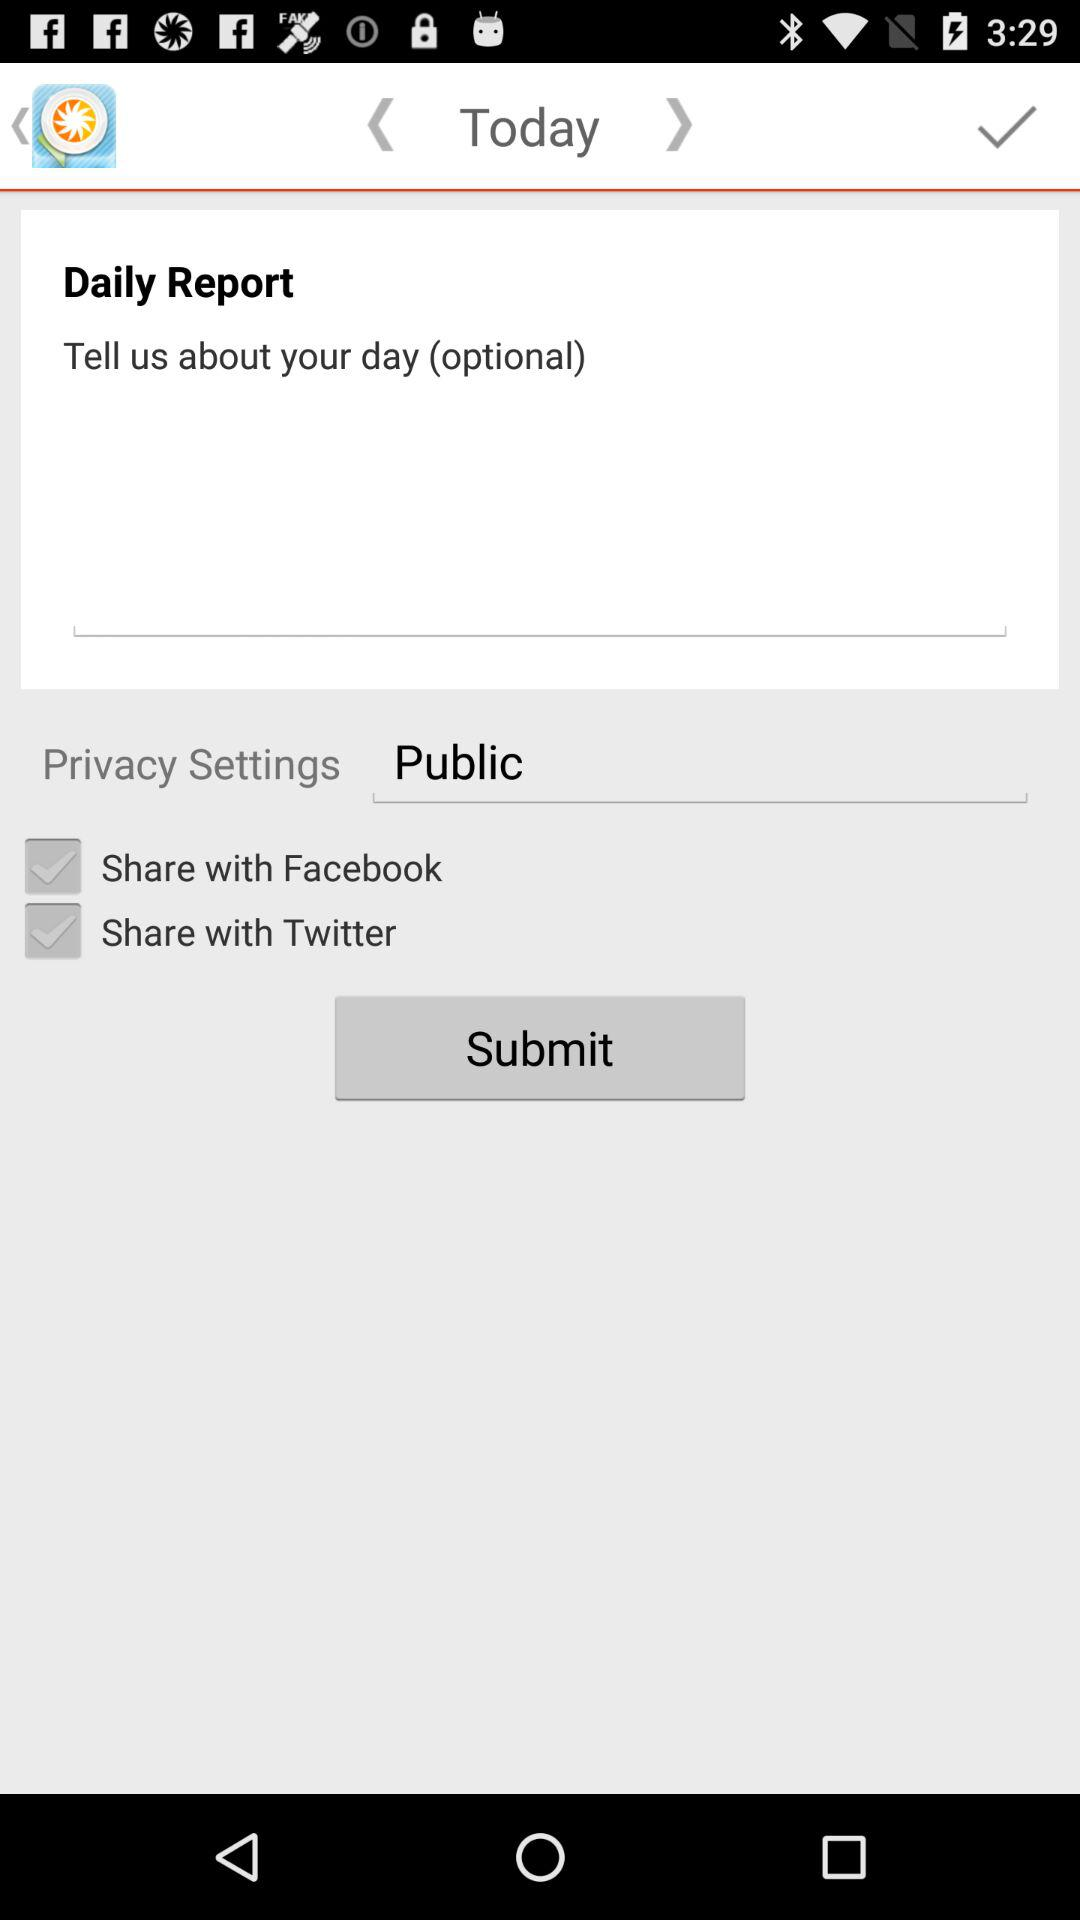What is the status for the share with public?
When the provided information is insufficient, respond with <no answer>. <no answer> 